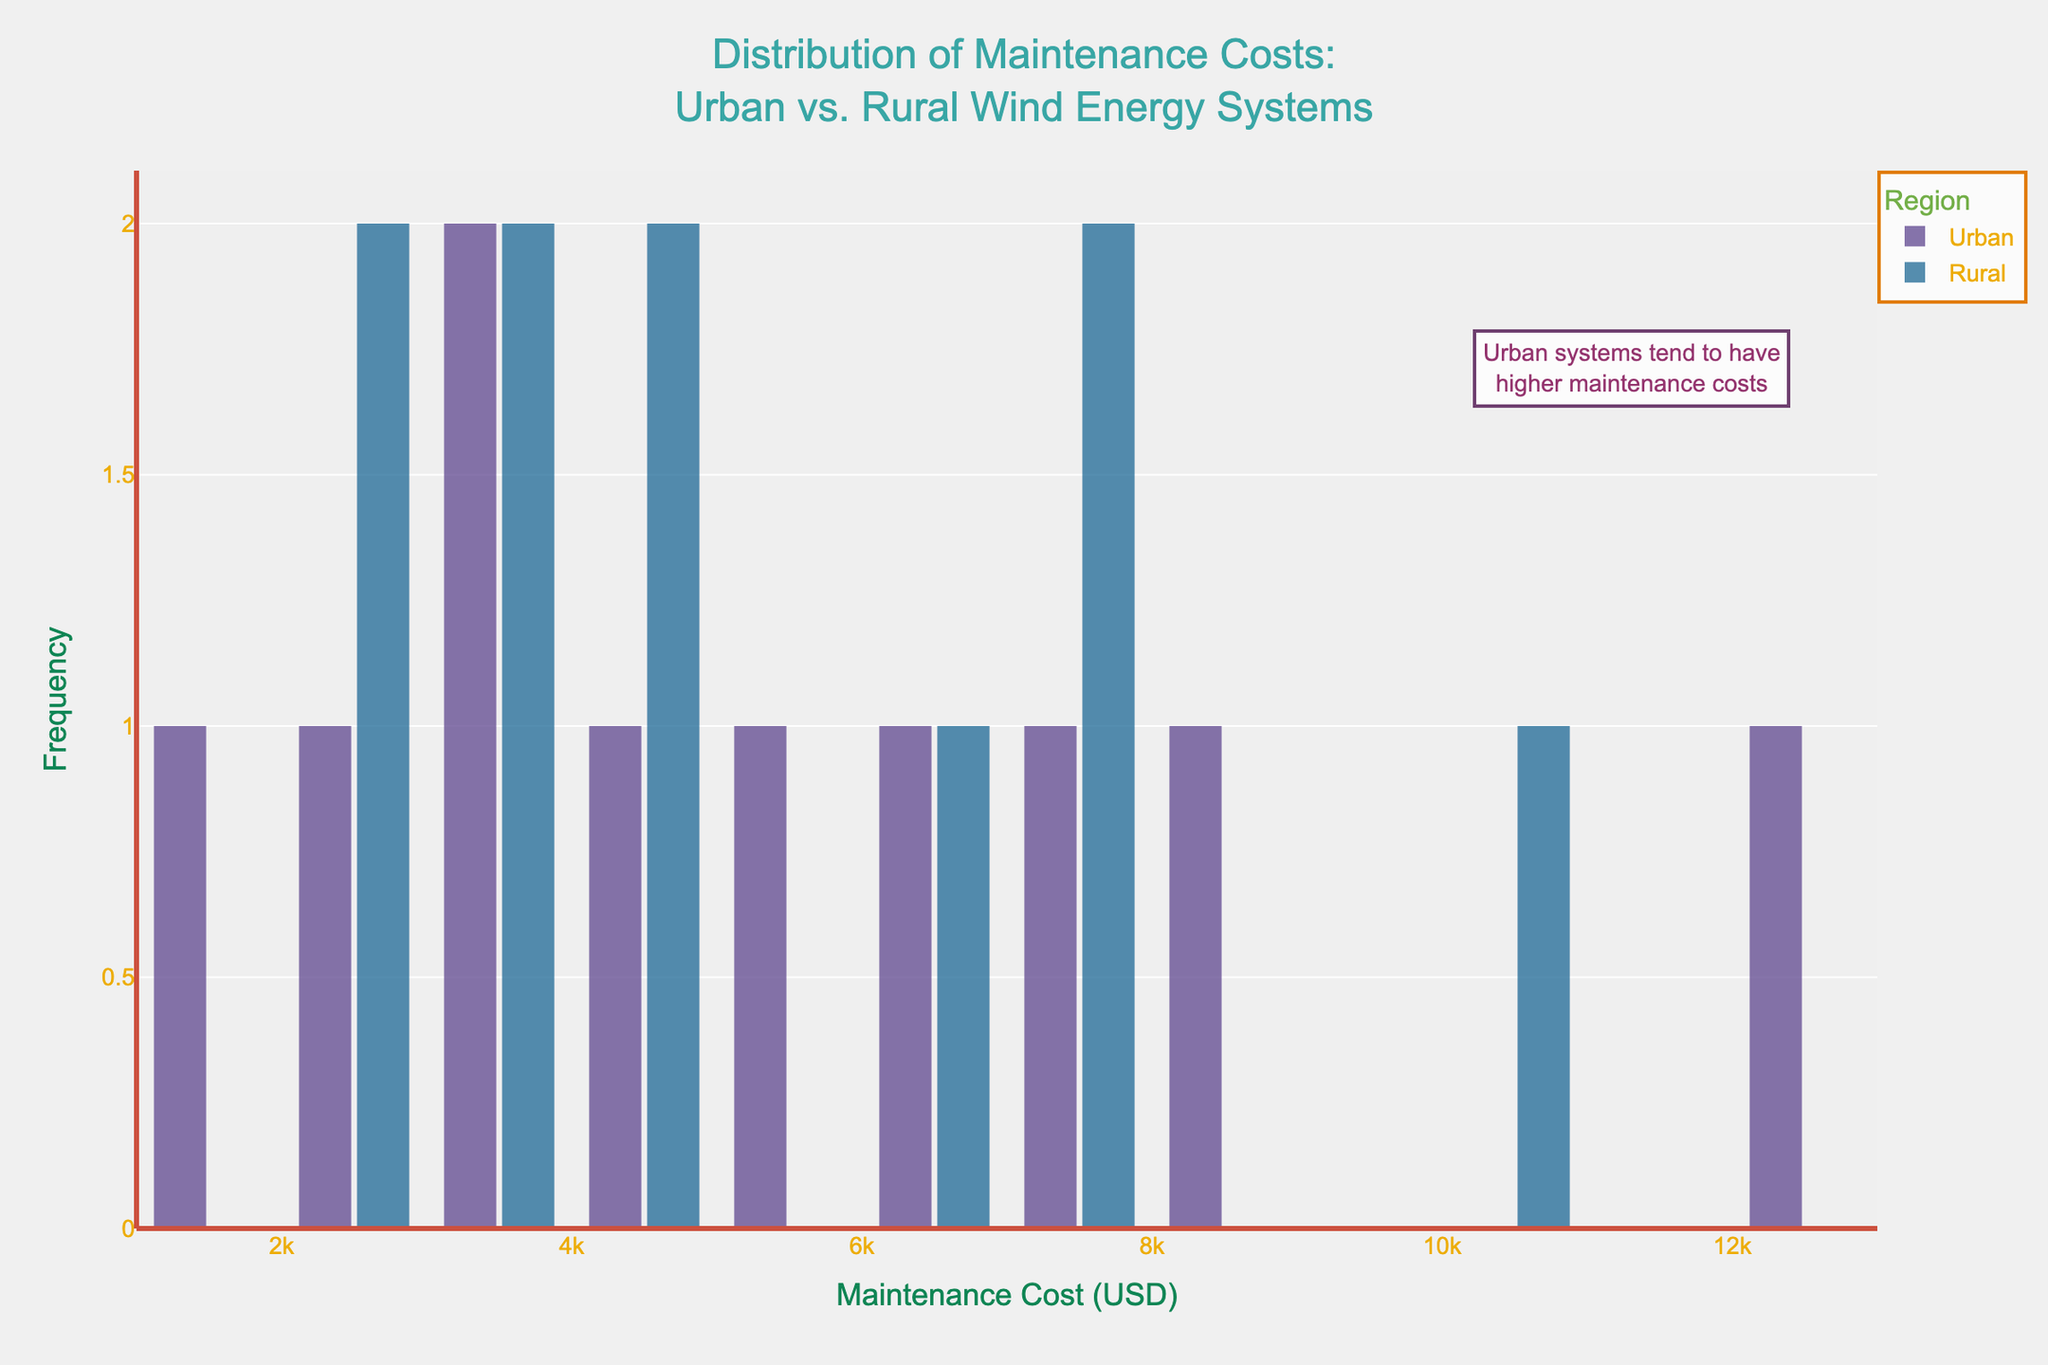What is the title of the plot? The title of the plot is displayed at the top of the figure with larger and bolder text. It generally summarizes what the plot is about.
Answer: Distribution of Maintenance Costs: Urban vs. Rural Wind Energy Systems What are the x-axis and y-axis labels? The labels for the x-axis and y-axis provide context for what the axes represent. You can find this information on the axes themselves.
Answer: x-axis: Maintenance Cost (USD), y-axis: Frequency Which region tends to have higher maintenance costs? By looking at the histograms, you can compare which region has more data points at higher cost ranges. In this plot, one region is highlighted with an annotation indicating higher costs.
Answer: Urban How many maintenance cost bins are used in the histogram for urban regions? To find the number of bins, you can count the separate vertical bars for the urban region in the histogram. This count will give the number of bins.
Answer: 20 What is the primary color used to represent rural data? The color can be identified by looking at the histogram bars corresponding to the rural region and checking the legend to confirm.
Answer: Second color in the Prism palette Which component in the urban region has the highest maintenance cost? The highest maintenance cost for a component in the urban region can be identified by finding the peak in the urban data. This can be cross-verified with the data.
Answer: Blades Which component in the rural region has the lowest maintenance cost? The lowest maintenance cost for a component in the rural region is the minimum value in the dataset for rural components. Cross-reference the dataset to find this value.
Answer: Lubrication System What is the median maintenance cost for rural regions? To find the median cost, you need to organize the maintenance costs for rural regions in ascending order and identify the middle value.
Answer: 4250 USD Are the maintenance costs more varied in urban or rural regions? Variation can be assessed by looking at the spread of the histogram. A wider spread indicates more variation.
Answer: Urban How is the annotation used in the plot helpful? The annotation highlights an important observation in the plot, making it easier for viewers to understand key insights without deep analysis. It typically points out trends or notable data points.
Answer: Points out that urban systems tend to have higher maintenance costs 